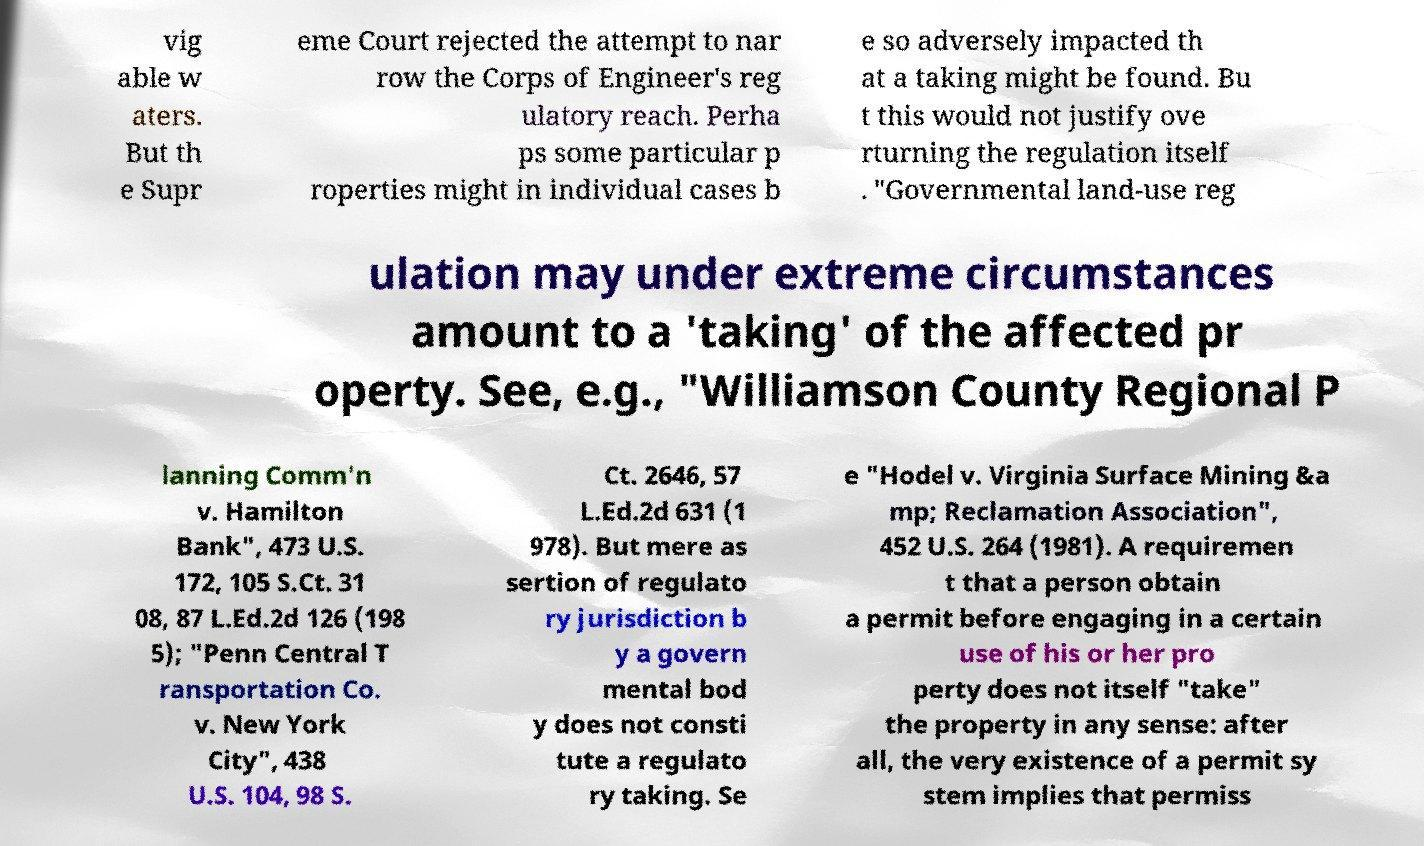What messages or text are displayed in this image? I need them in a readable, typed format. vig able w aters. But th e Supr eme Court rejected the attempt to nar row the Corps of Engineer's reg ulatory reach. Perha ps some particular p roperties might in individual cases b e so adversely impacted th at a taking might be found. Bu t this would not justify ove rturning the regulation itself . "Governmental land-use reg ulation may under extreme circumstances amount to a 'taking' of the affected pr operty. See, e.g., "Williamson County Regional P lanning Comm'n v. Hamilton Bank", 473 U.S. 172, 105 S.Ct. 31 08, 87 L.Ed.2d 126 (198 5); "Penn Central T ransportation Co. v. New York City", 438 U.S. 104, 98 S. Ct. 2646, 57 L.Ed.2d 631 (1 978). But mere as sertion of regulato ry jurisdiction b y a govern mental bod y does not consti tute a regulato ry taking. Se e "Hodel v. Virginia Surface Mining &a mp; Reclamation Association", 452 U.S. 264 (1981). A requiremen t that a person obtain a permit before engaging in a certain use of his or her pro perty does not itself "take" the property in any sense: after all, the very existence of a permit sy stem implies that permiss 